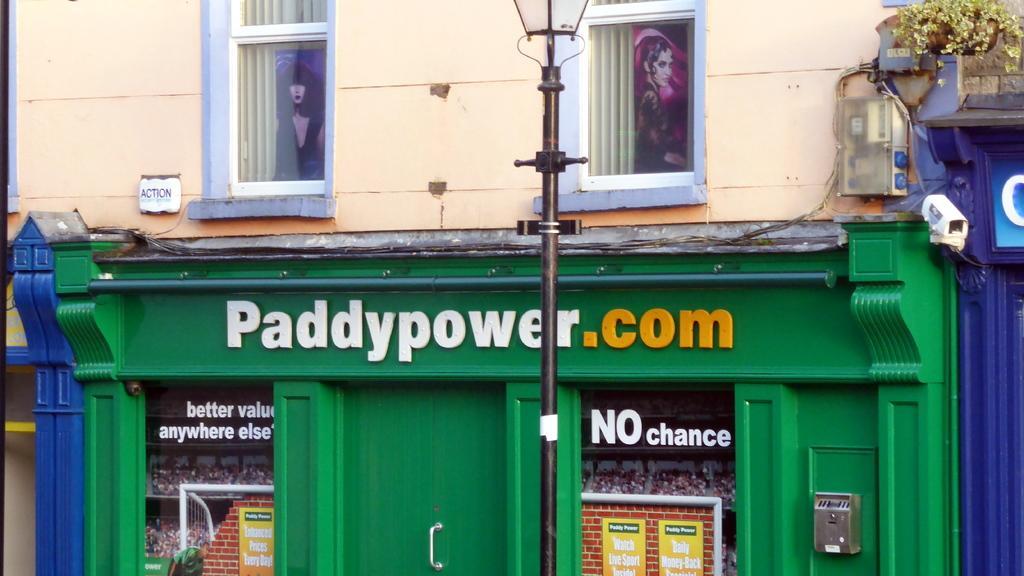Please provide a concise description of this image. In this image, we can see a building, walls, windows, curtains, posters, pole, wires, plant, door and few objects. 